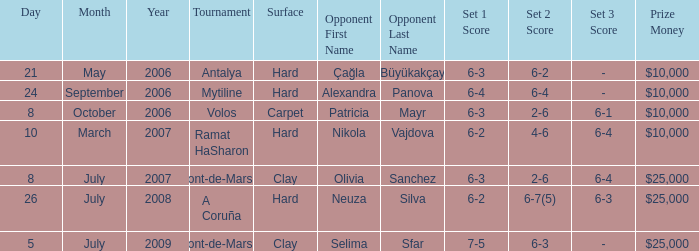What is the surface of the match on July 5, 2009? Clay. 